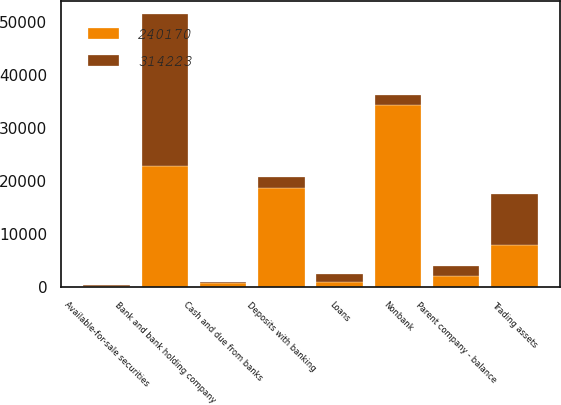Convert chart. <chart><loc_0><loc_0><loc_500><loc_500><stacked_bar_chart><ecel><fcel>Parent company - balance<fcel>Cash and due from banks<fcel>Deposits with banking<fcel>Trading assets<fcel>Available-for-sale securities<fcel>Loans<fcel>Bank and bank holding company<fcel>Nonbank<nl><fcel>314223<fcel>2007<fcel>110<fcel>2006.5<fcel>9563<fcel>43<fcel>1423<fcel>28705<fcel>2006.5<nl><fcel>240170<fcel>2006<fcel>756<fcel>18759<fcel>7975<fcel>257<fcel>971<fcel>22765<fcel>34282<nl></chart> 